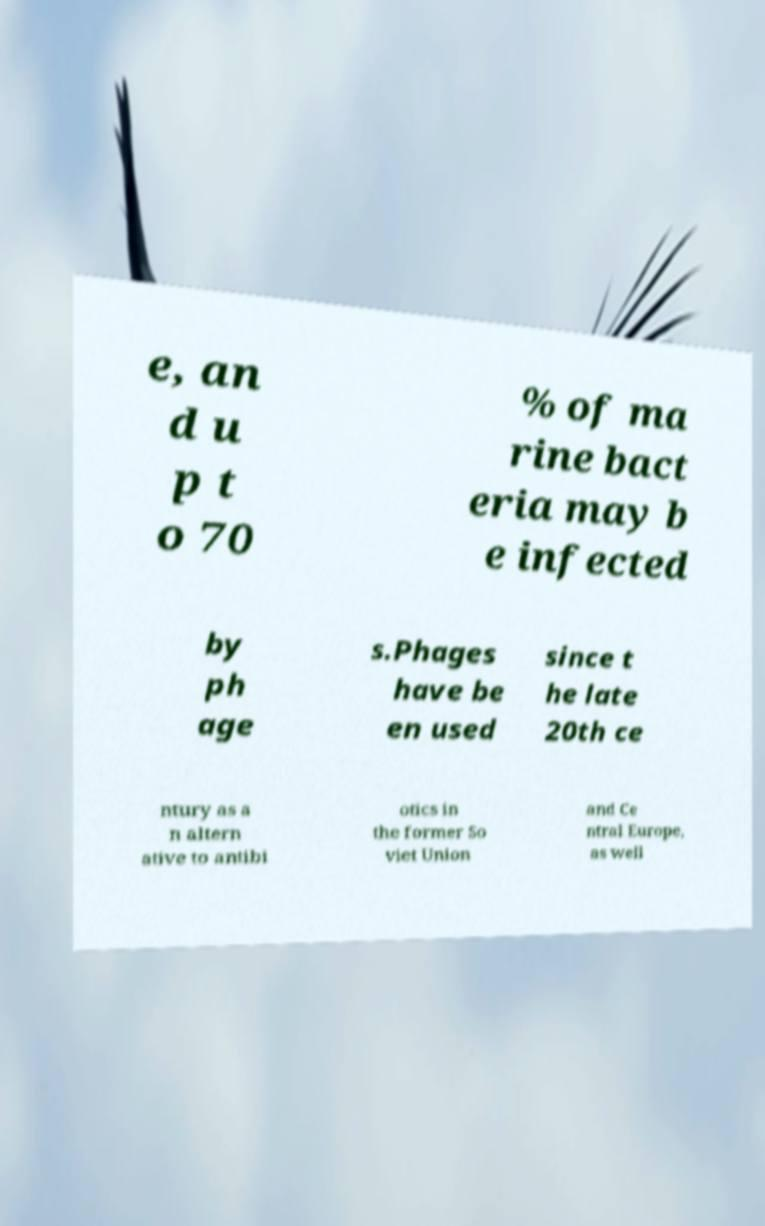Could you extract and type out the text from this image? e, an d u p t o 70 % of ma rine bact eria may b e infected by ph age s.Phages have be en used since t he late 20th ce ntury as a n altern ative to antibi otics in the former So viet Union and Ce ntral Europe, as well 